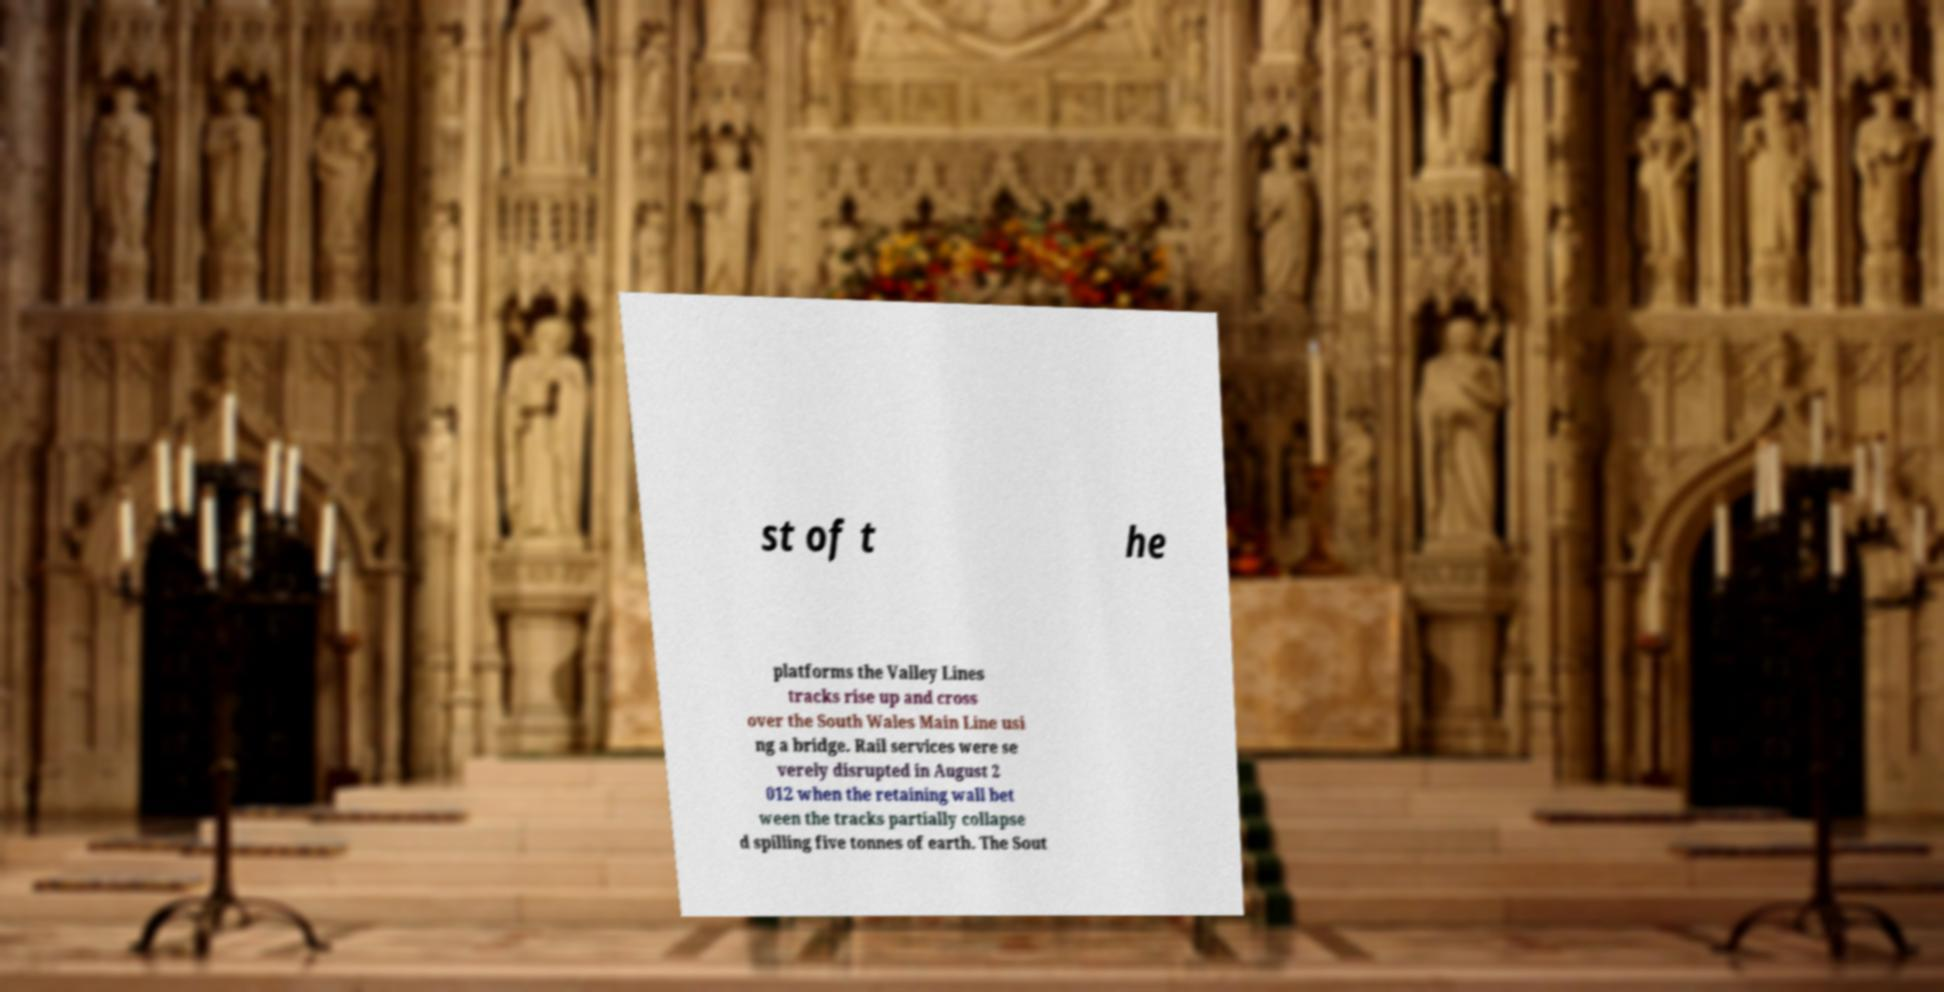Please identify and transcribe the text found in this image. st of t he platforms the Valley Lines tracks rise up and cross over the South Wales Main Line usi ng a bridge. Rail services were se verely disrupted in August 2 012 when the retaining wall bet ween the tracks partially collapse d spilling five tonnes of earth. The Sout 